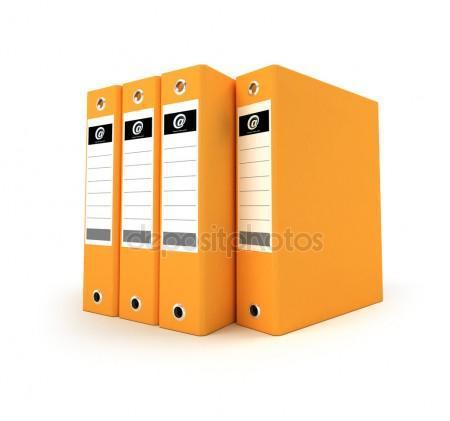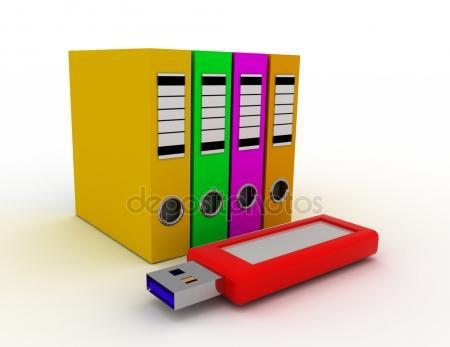The first image is the image on the left, the second image is the image on the right. Considering the images on both sides, is "There are four storage books of the same color in the left image." valid? Answer yes or no. Yes. 